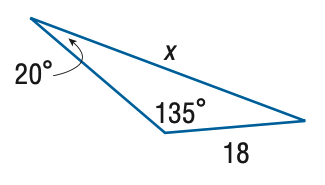Question: Find x. Round the side measure to the nearest tenth.
Choices:
A. 8.7
B. 14.6
C. 22.2
D. 37.2
Answer with the letter. Answer: D 